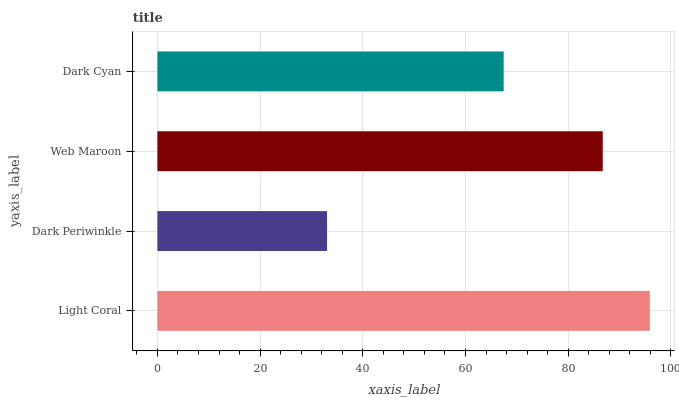Is Dark Periwinkle the minimum?
Answer yes or no. Yes. Is Light Coral the maximum?
Answer yes or no. Yes. Is Web Maroon the minimum?
Answer yes or no. No. Is Web Maroon the maximum?
Answer yes or no. No. Is Web Maroon greater than Dark Periwinkle?
Answer yes or no. Yes. Is Dark Periwinkle less than Web Maroon?
Answer yes or no. Yes. Is Dark Periwinkle greater than Web Maroon?
Answer yes or no. No. Is Web Maroon less than Dark Periwinkle?
Answer yes or no. No. Is Web Maroon the high median?
Answer yes or no. Yes. Is Dark Cyan the low median?
Answer yes or no. Yes. Is Dark Cyan the high median?
Answer yes or no. No. Is Web Maroon the low median?
Answer yes or no. No. 